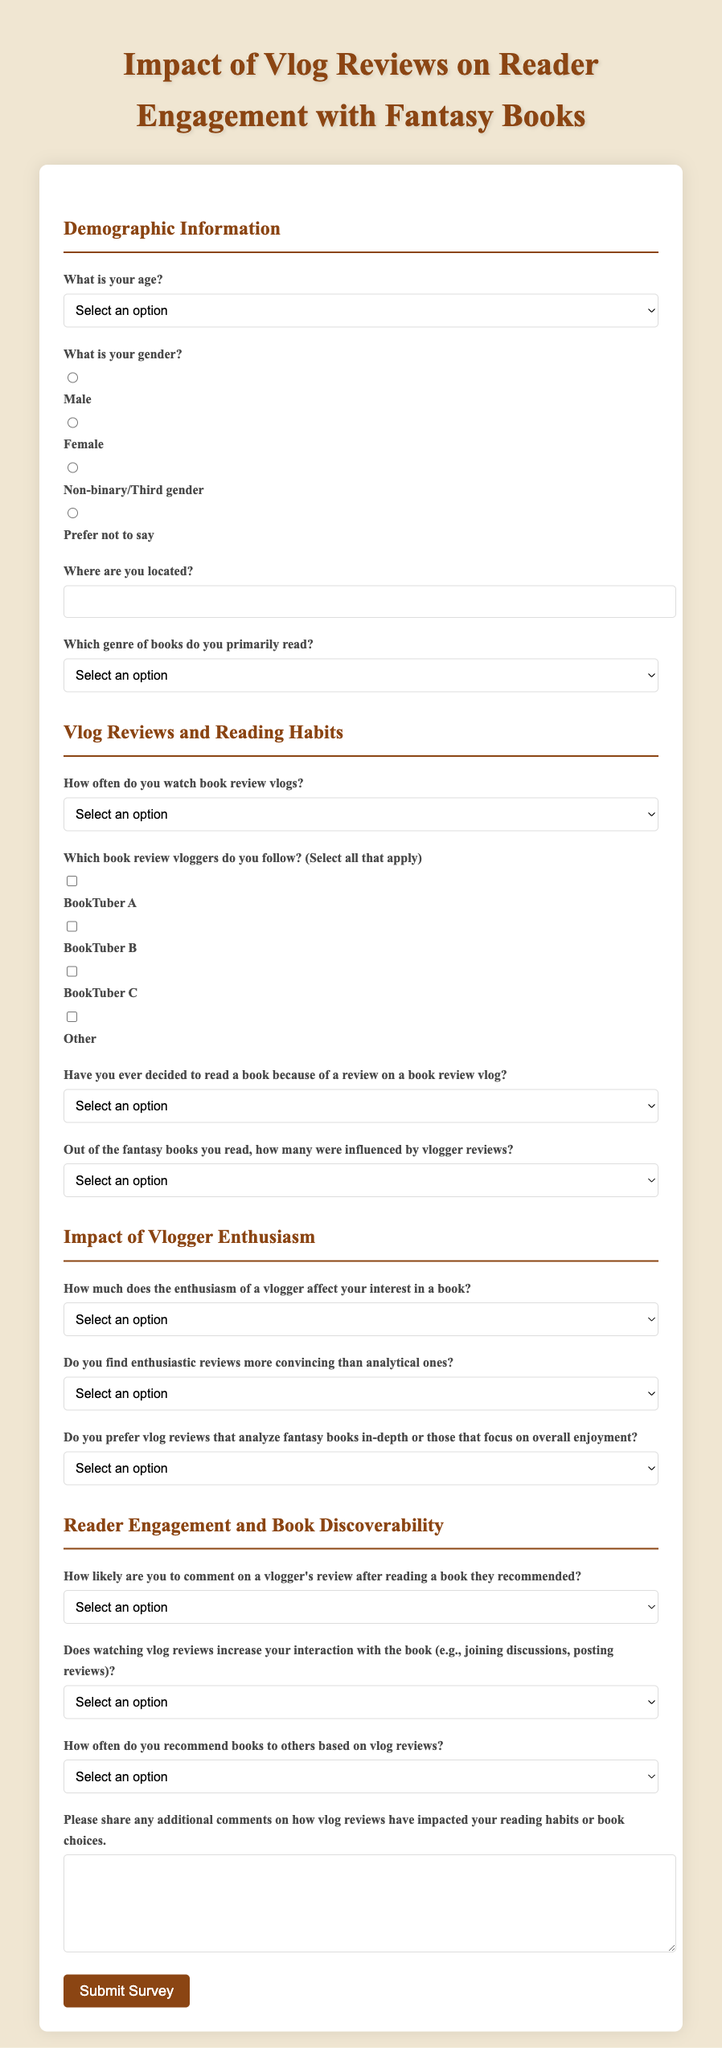What is the title of the survey? The title is prominently displayed at the top of the document, stating the focus on vlogger reviews and reader engagement.
Answer: Impact of Vlog Reviews on Reader Engagement with Fantasy Books How many options are provided for age selection? The age selection includes a dropdown menu with various age ranges for respondents to choose from.
Answer: 6 What type of input is required for the location field? The document specifies a text input field for users to enter their location.
Answer: Text input Which genre is primarily covered by this survey? The survey specifically asks respondents about the genre they primarily read, indicating the focus on a specific literary category.
Answer: Fantasy What is the maximum number of books respondents may report being influenced by vlogger reviews? The document provides response options for how many books were influenced, including a selection for more than five.
Answer: More than 5 books What are the options for how frequently respondents watch book review vlogs? The document lists several frequency options to ascertain viewing habits among respondents.
Answer: Daily, Weekly, Monthly, Rarely, Never What is the purpose of the additional comments section? This section allows respondents to elaborate on their experiences related to vlog reviews and their reading habits.
Answer: Elaborate on experiences Do respondents receive a button to submit the survey? The document provides a clearly labeled button for users to submit their completed survey once answered.
Answer: Yes 